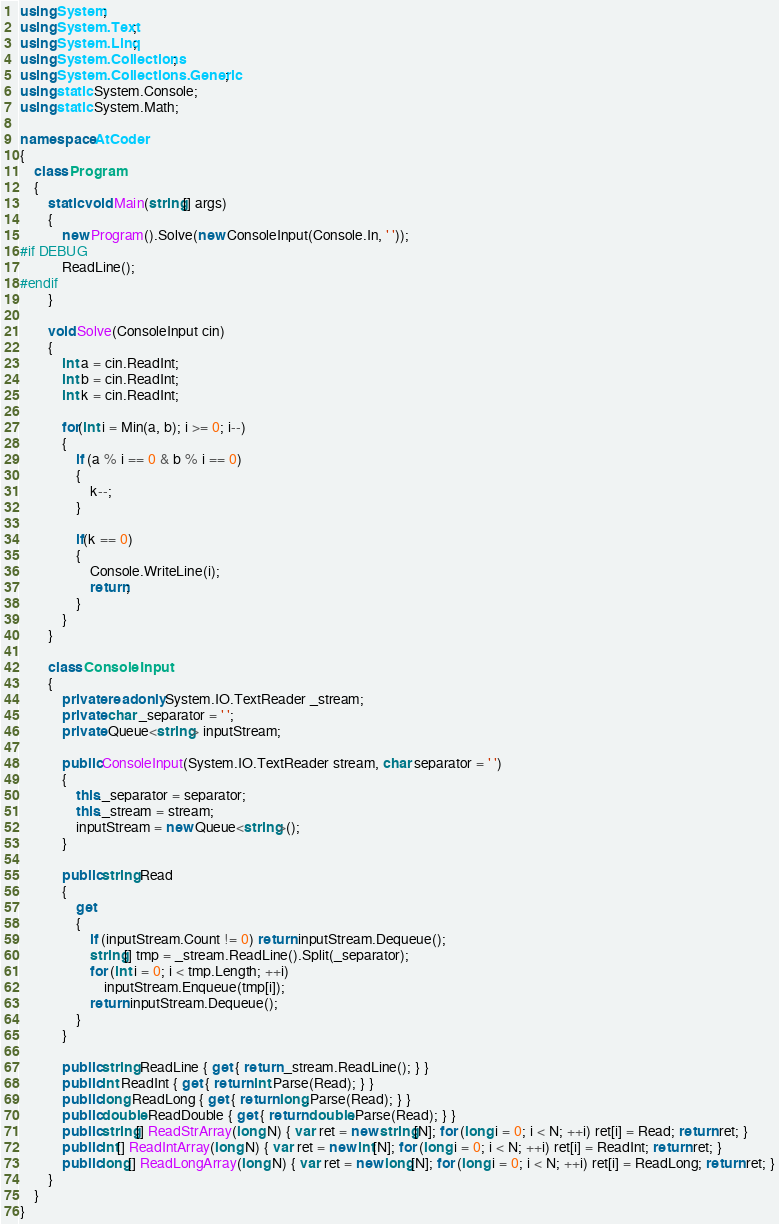<code> <loc_0><loc_0><loc_500><loc_500><_C#_>using System;
using System.Text;
using System.Linq;
using System.Collections;
using System.Collections.Generic;
using static System.Console;
using static System.Math;

namespace AtCoder
{
    class Program
    {
        static void Main(string[] args)
        {
            new Program().Solve(new ConsoleInput(Console.In, ' '));
#if DEBUG
            ReadLine();
#endif
        }

        void Solve(ConsoleInput cin)
        {
            int a = cin.ReadInt;
            int b = cin.ReadInt;
            int k = cin.ReadInt;
            
            for(int i = Min(a, b); i >= 0; i--)
            {
                if (a % i == 0 & b % i == 0)
                {
                    k--;
                }

                if(k == 0)
                {
                    Console.WriteLine(i);
                    return;
                }
            }
        }

        class ConsoleInput
        {
            private readonly System.IO.TextReader _stream;
            private char _separator = ' ';
            private Queue<string> inputStream;

            public ConsoleInput(System.IO.TextReader stream, char separator = ' ')
            {
                this._separator = separator;
                this._stream = stream;
                inputStream = new Queue<string>();
            }

            public string Read
            {
                get
                {
                    if (inputStream.Count != 0) return inputStream.Dequeue();
                    string[] tmp = _stream.ReadLine().Split(_separator);
                    for (int i = 0; i < tmp.Length; ++i)
                        inputStream.Enqueue(tmp[i]);
                    return inputStream.Dequeue();
                }
            }

            public string ReadLine { get { return _stream.ReadLine(); } }
            public int ReadInt { get { return int.Parse(Read); } }
            public long ReadLong { get { return long.Parse(Read); } }
            public double ReadDouble { get { return double.Parse(Read); } }
            public string[] ReadStrArray(long N) { var ret = new string[N]; for (long i = 0; i < N; ++i) ret[i] = Read; return ret; }
            public int[] ReadIntArray(long N) { var ret = new int[N]; for (long i = 0; i < N; ++i) ret[i] = ReadInt; return ret; }
            public long[] ReadLongArray(long N) { var ret = new long[N]; for (long i = 0; i < N; ++i) ret[i] = ReadLong; return ret; }
        }
    }
}</code> 